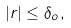<formula> <loc_0><loc_0><loc_500><loc_500>| r | \leq \delta _ { o } ,</formula> 